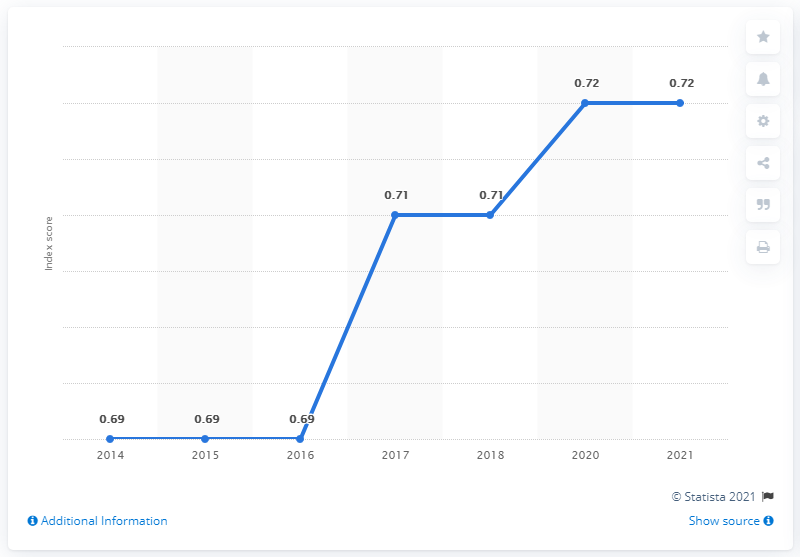List a handful of essential elements in this visual. In 2021, Honduras had a gender gap index score of 0.72, which indicates that while there have been some gains in gender equality, significant disparities remain in areas such as political representation and economic participation. 